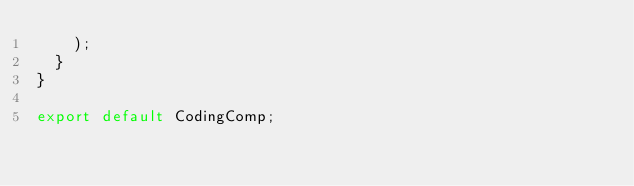<code> <loc_0><loc_0><loc_500><loc_500><_JavaScript_>    );
  }
}

export default CodingComp;
</code> 